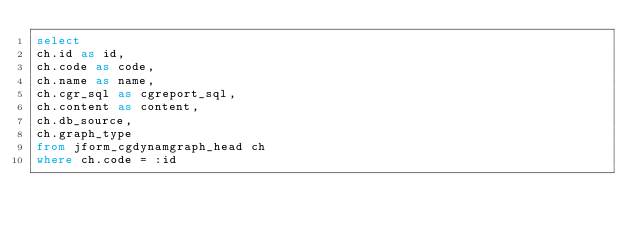Convert code to text. <code><loc_0><loc_0><loc_500><loc_500><_SQL_>select 
ch.id as id,
ch.code as code,
ch.name as name,
ch.cgr_sql as cgreport_sql,
ch.content as content,
ch.db_source,
ch.graph_type
from jform_cgdynamgraph_head ch
where ch.code = :id</code> 